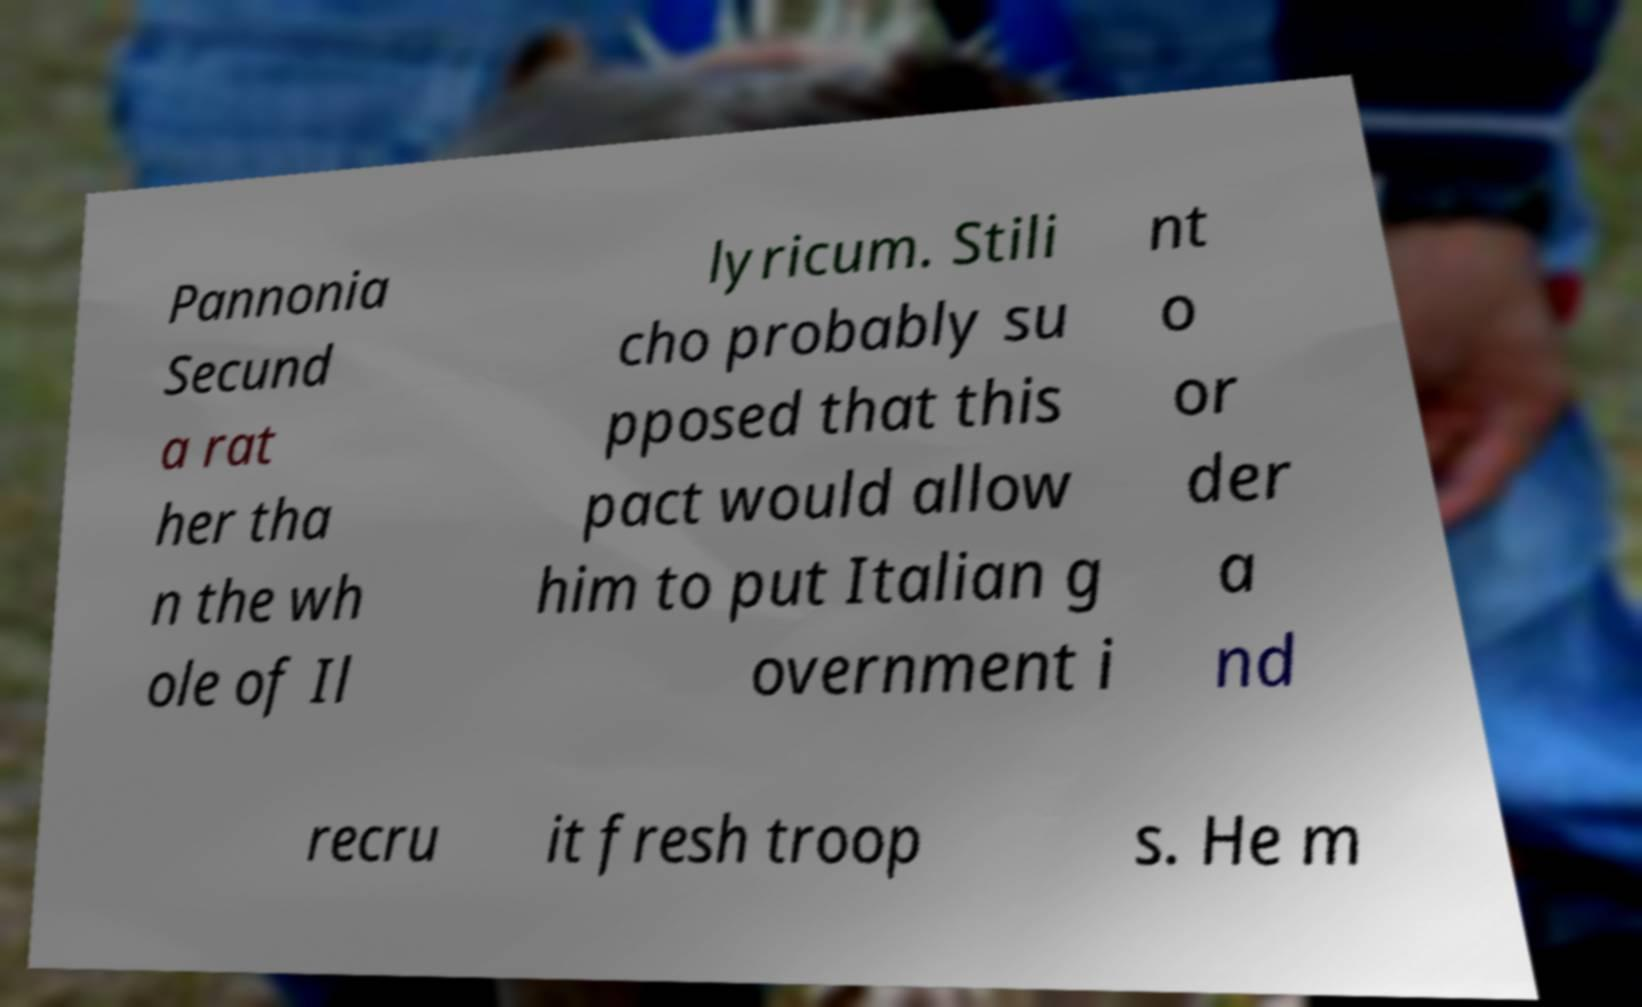Please identify and transcribe the text found in this image. Pannonia Secund a rat her tha n the wh ole of Il lyricum. Stili cho probably su pposed that this pact would allow him to put Italian g overnment i nt o or der a nd recru it fresh troop s. He m 